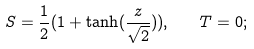<formula> <loc_0><loc_0><loc_500><loc_500>S = \frac { 1 } { 2 } ( 1 + \tanh ( \frac { z } { \sqrt { 2 } } ) ) , \quad T = 0 ;</formula> 